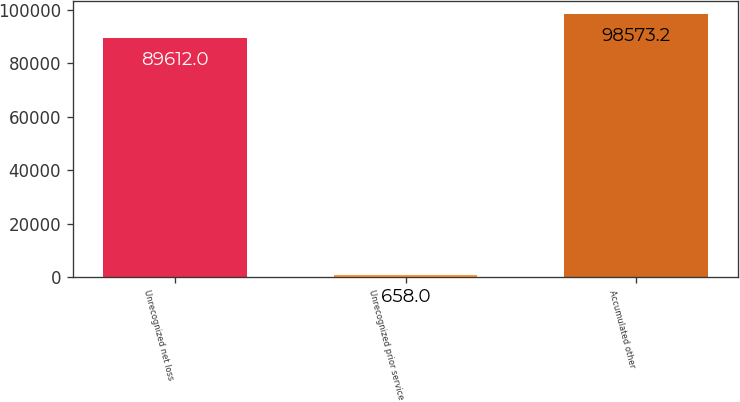Convert chart to OTSL. <chart><loc_0><loc_0><loc_500><loc_500><bar_chart><fcel>Unrecognized net loss<fcel>Unrecognized prior service<fcel>Accumulated other<nl><fcel>89612<fcel>658<fcel>98573.2<nl></chart> 